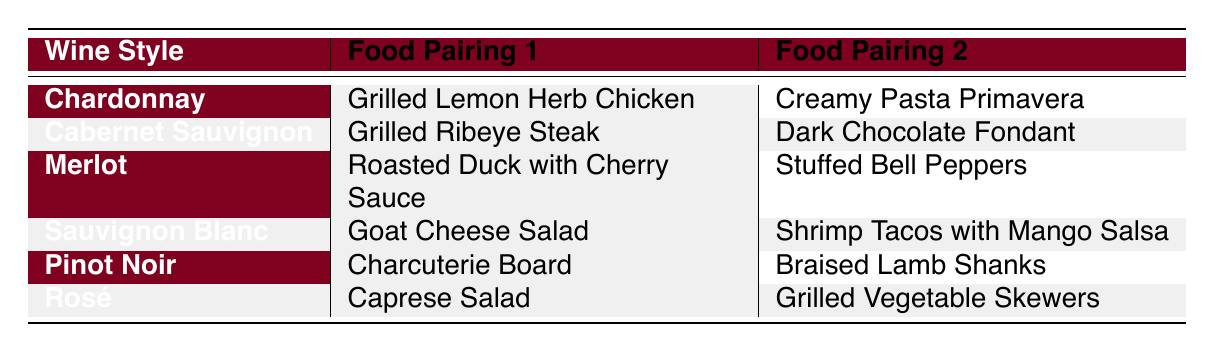What are two food pairings for Chardonnay? The table lists "Grilled Lemon Herb Chicken" and "Creamy Pasta Primavera" as the two food pairings for Chardonnay.
Answer: Grilled Lemon Herb Chicken, Creamy Pasta Primavera Which wine style pairs with Dark Chocolate Fondant? The table shows that "Dark Chocolate Fondant" is paired with "Cabernet Sauvignon."
Answer: Cabernet Sauvignon Is there a food pairing for Rosé that includes salad? Referring to the table, "Caprese Salad" is listed as a food pairing for Rosé, which confirms that there is indeed a salad pairing.
Answer: Yes How many different food pairings are suggested for Sauvignon Blanc? The table shows two food pairings for Sauvignon Blanc: "Goat Cheese Salad" and "Shrimp Tacos with Mango Salsa." Hence, there are two pairings.
Answer: 2 Which wine style recommended the food pairing "Braised Lamb Shanks"? The table indicates that "Braised Lamb Shanks" is paired with "Pinot Noir."
Answer: Pinot Noir What is the total number of food pairings listed for all wine styles? Counting all pairings from the table, there are 12 food pairings in total, as each of the six wine styles has two pairings.
Answer: 12 Are there any food pairings that involve chicken? Looking at the table, the food pairing "Grilled Lemon Herb Chicken" under the Chardonnay wine style confirms that there is a chicken pairing.
Answer: Yes Which wine style has a food pairing that includes mango salsa? The food pairing "Shrimp Tacos with Mango Salsa" is listed under the Sauvignon Blanc wine style.
Answer: Sauvignon Blanc What is the difference in the number of food pairings between Cabernet Sauvignon and Merlot? Both Cabernet Sauvignon and Merlot have two food pairings each, resulting in a difference of 0.
Answer: 0 